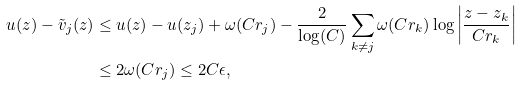<formula> <loc_0><loc_0><loc_500><loc_500>u ( z ) - \tilde { v } _ { j } ( z ) & \leq u ( z ) - u ( z _ { j } ) + \omega ( C r _ { j } ) - \frac { 2 } { \log ( C ) } \sum _ { k \neq j } \omega ( C r _ { k } ) \log \left | \frac { z - z _ { k } } { C r _ { k } } \right | \\ & \leq 2 \omega ( C r _ { j } ) \leq 2 C \epsilon ,</formula> 